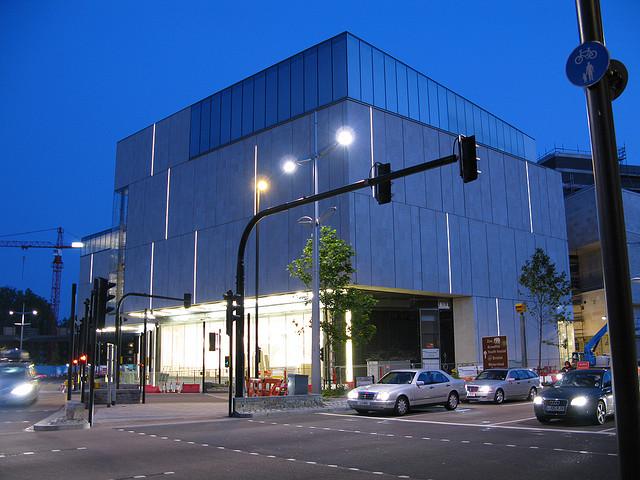What is the pattern on the building?
Quick response, please. Rectangles. How many cars are visible in this picture?
Keep it brief. 4. Is the sky blue?
Concise answer only. Yes. Why the lights are on?
Give a very brief answer. Dark. 